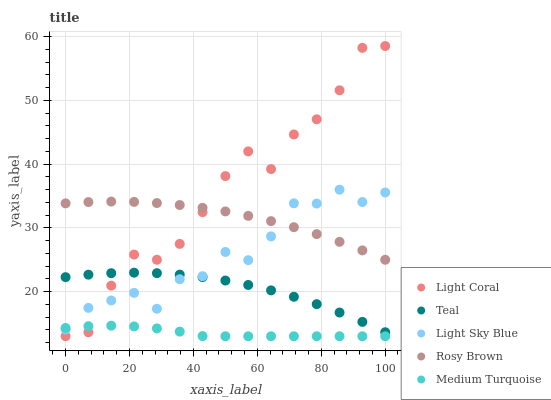Does Medium Turquoise have the minimum area under the curve?
Answer yes or no. Yes. Does Light Coral have the maximum area under the curve?
Answer yes or no. Yes. Does Rosy Brown have the minimum area under the curve?
Answer yes or no. No. Does Rosy Brown have the maximum area under the curve?
Answer yes or no. No. Is Rosy Brown the smoothest?
Answer yes or no. Yes. Is Light Coral the roughest?
Answer yes or no. Yes. Is Light Sky Blue the smoothest?
Answer yes or no. No. Is Light Sky Blue the roughest?
Answer yes or no. No. Does Medium Turquoise have the lowest value?
Answer yes or no. Yes. Does Light Sky Blue have the lowest value?
Answer yes or no. No. Does Light Coral have the highest value?
Answer yes or no. Yes. Does Rosy Brown have the highest value?
Answer yes or no. No. Is Medium Turquoise less than Teal?
Answer yes or no. Yes. Is Rosy Brown greater than Medium Turquoise?
Answer yes or no. Yes. Does Light Coral intersect Medium Turquoise?
Answer yes or no. Yes. Is Light Coral less than Medium Turquoise?
Answer yes or no. No. Is Light Coral greater than Medium Turquoise?
Answer yes or no. No. Does Medium Turquoise intersect Teal?
Answer yes or no. No. 